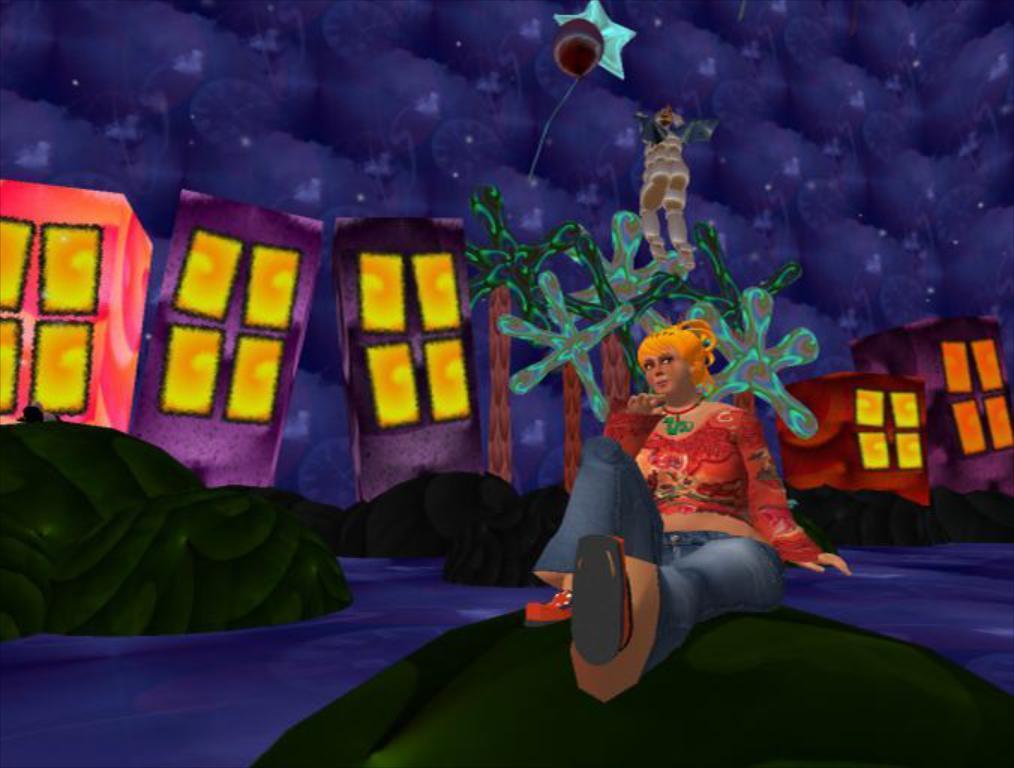In one or two sentences, can you explain what this image depicts? In this image, we can see depiction of a person. There are buildings and rocks in the middle of the image. There is a river at the bottom of the image. 